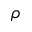<formula> <loc_0><loc_0><loc_500><loc_500>\rho</formula> 